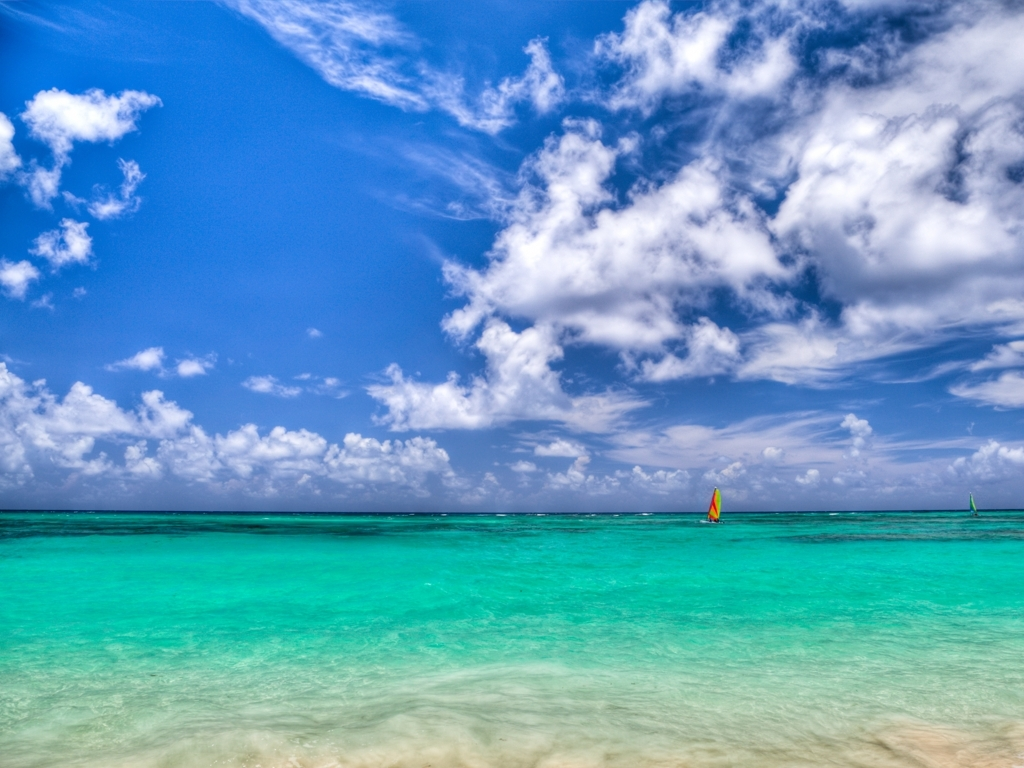How is the lighting in the image?
A. The lighting in the image is excessive.
B. The lighting in the image is dim.
C. The lighting in the image is sufficient.
Answer with the option's letter from the given choices directly.
 C. 